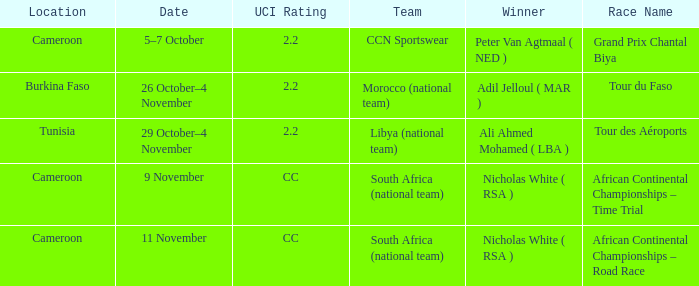What is the location of the race on 11 November? Cameroon. 